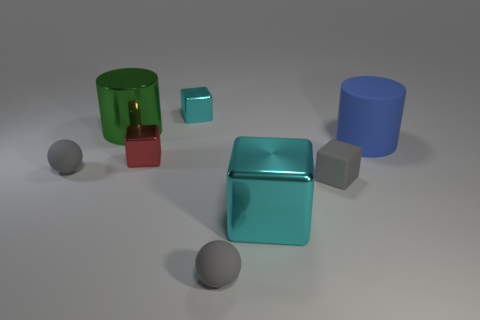Subtract all large cyan blocks. How many blocks are left? 3 Subtract all brown cylinders. How many cyan cubes are left? 2 Subtract all gray cubes. How many cubes are left? 3 Subtract all yellow cubes. Subtract all gray balls. How many cubes are left? 4 Add 2 large red cylinders. How many objects exist? 10 Subtract all cylinders. How many objects are left? 6 Add 8 small matte cubes. How many small matte cubes are left? 9 Add 6 large brown shiny cubes. How many large brown shiny cubes exist? 6 Subtract 0 yellow cylinders. How many objects are left? 8 Subtract all matte cylinders. Subtract all tiny cyan objects. How many objects are left? 6 